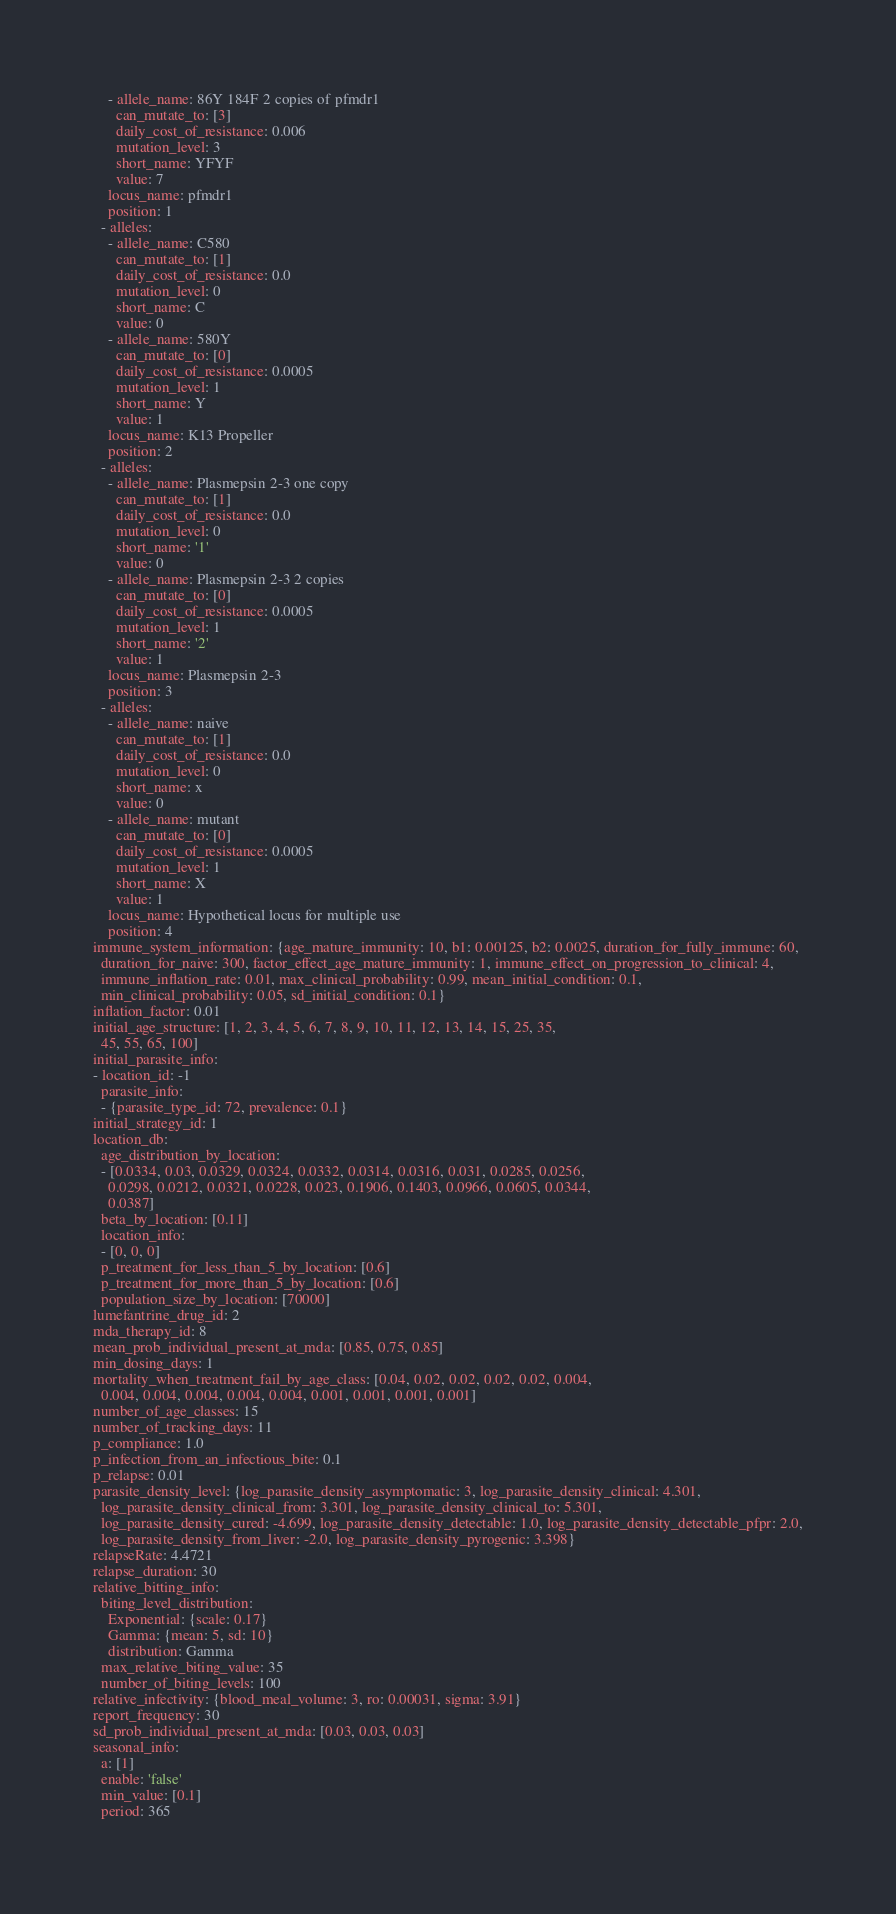<code> <loc_0><loc_0><loc_500><loc_500><_YAML_>    - allele_name: 86Y 184F 2 copies of pfmdr1
      can_mutate_to: [3]
      daily_cost_of_resistance: 0.006
      mutation_level: 3
      short_name: YFYF
      value: 7
    locus_name: pfmdr1
    position: 1
  - alleles:
    - allele_name: C580
      can_mutate_to: [1]
      daily_cost_of_resistance: 0.0
      mutation_level: 0
      short_name: C
      value: 0
    - allele_name: 580Y
      can_mutate_to: [0]
      daily_cost_of_resistance: 0.0005
      mutation_level: 1
      short_name: Y
      value: 1
    locus_name: K13 Propeller
    position: 2
  - alleles:
    - allele_name: Plasmepsin 2-3 one copy
      can_mutate_to: [1]
      daily_cost_of_resistance: 0.0
      mutation_level: 0
      short_name: '1'
      value: 0
    - allele_name: Plasmepsin 2-3 2 copies
      can_mutate_to: [0]
      daily_cost_of_resistance: 0.0005
      mutation_level: 1
      short_name: '2'
      value: 1
    locus_name: Plasmepsin 2-3
    position: 3
  - alleles:
    - allele_name: naive
      can_mutate_to: [1]
      daily_cost_of_resistance: 0.0
      mutation_level: 0
      short_name: x
      value: 0
    - allele_name: mutant
      can_mutate_to: [0]
      daily_cost_of_resistance: 0.0005
      mutation_level: 1
      short_name: X
      value: 1
    locus_name: Hypothetical locus for multiple use
    position: 4
immune_system_information: {age_mature_immunity: 10, b1: 0.00125, b2: 0.0025, duration_for_fully_immune: 60,
  duration_for_naive: 300, factor_effect_age_mature_immunity: 1, immune_effect_on_progression_to_clinical: 4,
  immune_inflation_rate: 0.01, max_clinical_probability: 0.99, mean_initial_condition: 0.1,
  min_clinical_probability: 0.05, sd_initial_condition: 0.1}
inflation_factor: 0.01
initial_age_structure: [1, 2, 3, 4, 5, 6, 7, 8, 9, 10, 11, 12, 13, 14, 15, 25, 35,
  45, 55, 65, 100]
initial_parasite_info:
- location_id: -1
  parasite_info:
  - {parasite_type_id: 72, prevalence: 0.1}
initial_strategy_id: 1
location_db:
  age_distribution_by_location:
  - [0.0334, 0.03, 0.0329, 0.0324, 0.0332, 0.0314, 0.0316, 0.031, 0.0285, 0.0256,
    0.0298, 0.0212, 0.0321, 0.0228, 0.023, 0.1906, 0.1403, 0.0966, 0.0605, 0.0344,
    0.0387]
  beta_by_location: [0.11]
  location_info:
  - [0, 0, 0]
  p_treatment_for_less_than_5_by_location: [0.6]
  p_treatment_for_more_than_5_by_location: [0.6]
  population_size_by_location: [70000]
lumefantrine_drug_id: 2
mda_therapy_id: 8
mean_prob_individual_present_at_mda: [0.85, 0.75, 0.85]
min_dosing_days: 1
mortality_when_treatment_fail_by_age_class: [0.04, 0.02, 0.02, 0.02, 0.02, 0.004,
  0.004, 0.004, 0.004, 0.004, 0.004, 0.001, 0.001, 0.001, 0.001]
number_of_age_classes: 15
number_of_tracking_days: 11
p_compliance: 1.0
p_infection_from_an_infectious_bite: 0.1
p_relapse: 0.01
parasite_density_level: {log_parasite_density_asymptomatic: 3, log_parasite_density_clinical: 4.301,
  log_parasite_density_clinical_from: 3.301, log_parasite_density_clinical_to: 5.301,
  log_parasite_density_cured: -4.699, log_parasite_density_detectable: 1.0, log_parasite_density_detectable_pfpr: 2.0,
  log_parasite_density_from_liver: -2.0, log_parasite_density_pyrogenic: 3.398}
relapseRate: 4.4721
relapse_duration: 30
relative_bitting_info:
  biting_level_distribution:
    Exponential: {scale: 0.17}
    Gamma: {mean: 5, sd: 10}
    distribution: Gamma
  max_relative_biting_value: 35
  number_of_biting_levels: 100
relative_infectivity: {blood_meal_volume: 3, ro: 0.00031, sigma: 3.91}
report_frequency: 30
sd_prob_individual_present_at_mda: [0.03, 0.03, 0.03]
seasonal_info:
  a: [1]
  enable: 'false'
  min_value: [0.1]
  period: 365</code> 